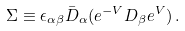Convert formula to latex. <formula><loc_0><loc_0><loc_500><loc_500>\Sigma \equiv \epsilon _ { \alpha \beta } { \bar { D } } _ { \alpha } ( e ^ { - V } D _ { \beta } e ^ { V } ) \, .</formula> 